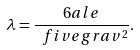Convert formula to latex. <formula><loc_0><loc_0><loc_500><loc_500>\lambda = \frac { 6 a l e } { \ f i v e g r a v ^ { 2 } } .</formula> 